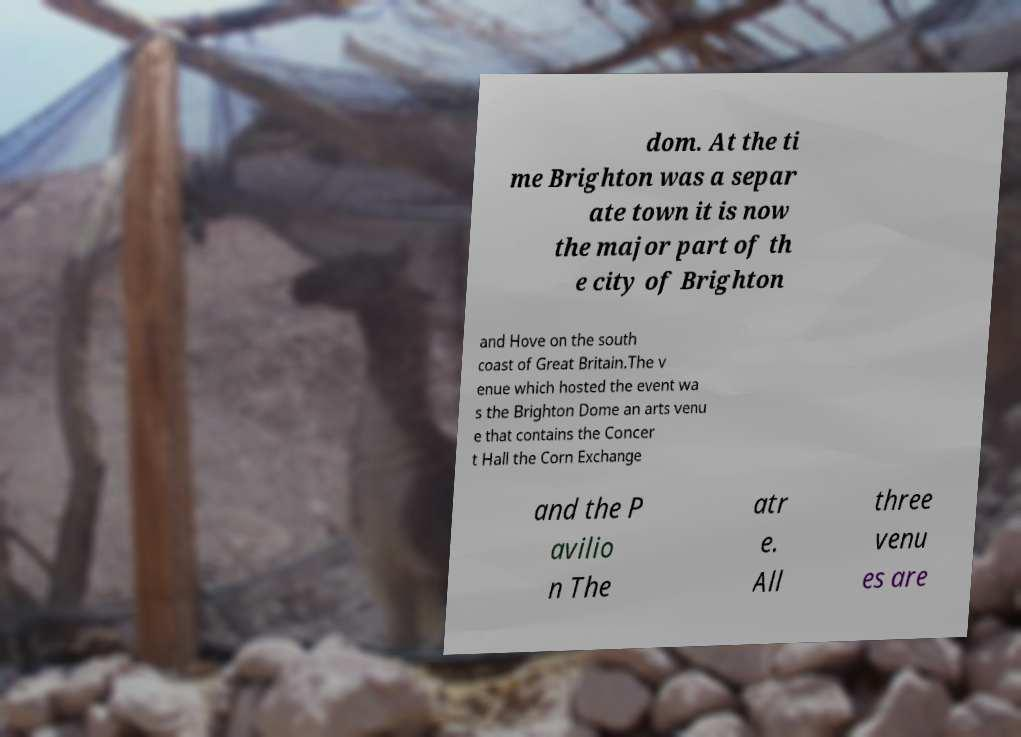There's text embedded in this image that I need extracted. Can you transcribe it verbatim? dom. At the ti me Brighton was a separ ate town it is now the major part of th e city of Brighton and Hove on the south coast of Great Britain.The v enue which hosted the event wa s the Brighton Dome an arts venu e that contains the Concer t Hall the Corn Exchange and the P avilio n The atr e. All three venu es are 